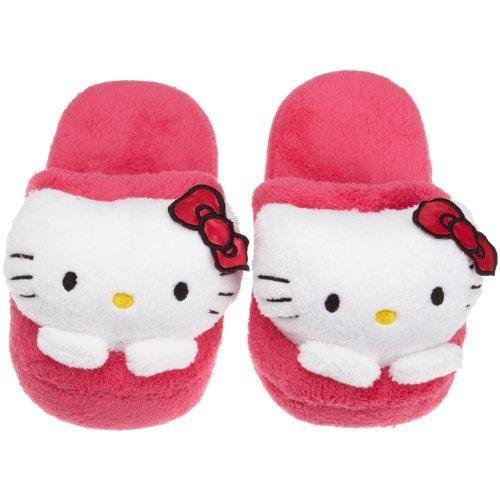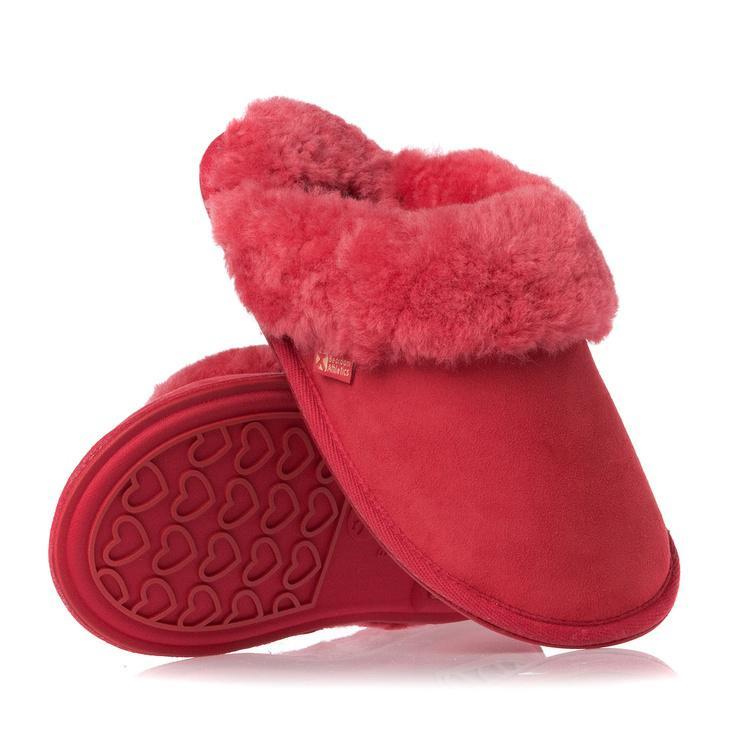The first image is the image on the left, the second image is the image on the right. For the images displayed, is the sentence "The left image features a slipper style with an animal face on the top, and the right image shows a matching pair of fur-trimmed slippers." factually correct? Answer yes or no. Yes. The first image is the image on the left, the second image is the image on the right. Given the left and right images, does the statement "Two pairs of slippers are pink, but different styles, one of them a solid pink color with same color furry trim element." hold true? Answer yes or no. Yes. 